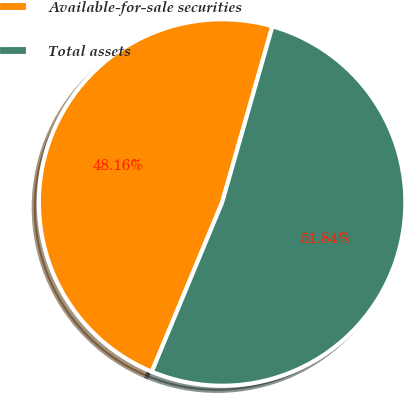Convert chart. <chart><loc_0><loc_0><loc_500><loc_500><pie_chart><fcel>Available-for-sale securities<fcel>Total assets<nl><fcel>48.16%<fcel>51.84%<nl></chart> 